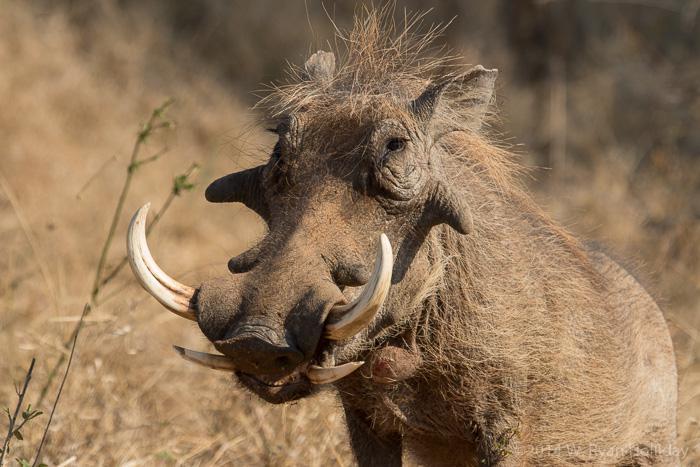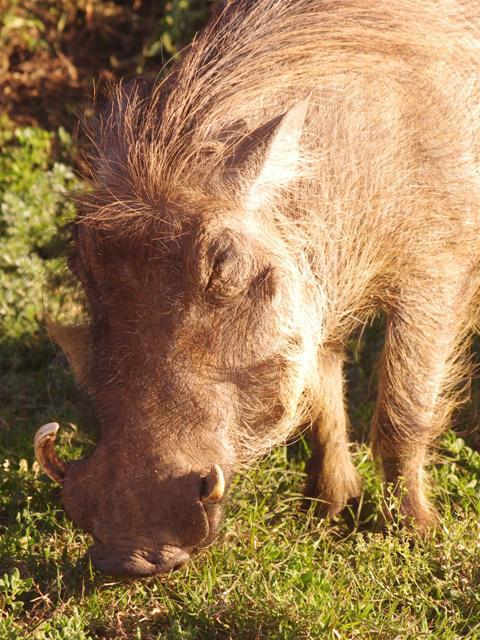The first image is the image on the left, the second image is the image on the right. For the images shown, is this caption "There are no more than 3 hogs in total." true? Answer yes or no. Yes. The first image is the image on the left, the second image is the image on the right. Analyze the images presented: Is the assertion "An image contains only young hogs, all without distinctive patterned fur." valid? Answer yes or no. No. 